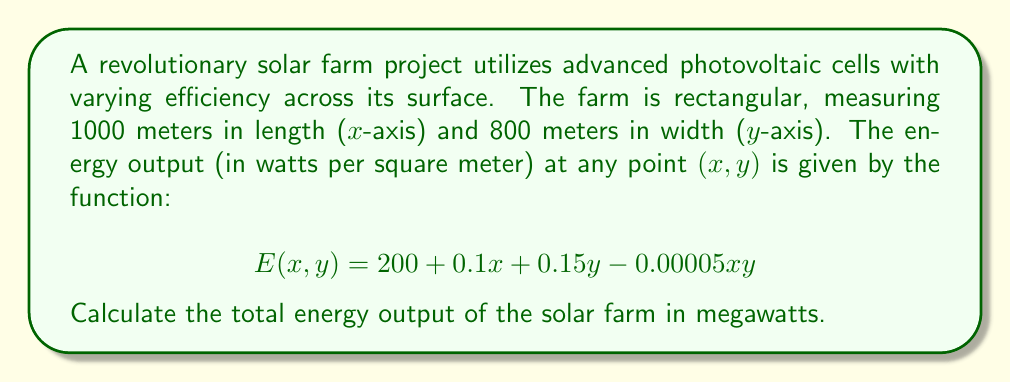Can you answer this question? To calculate the total energy output of the solar farm, we need to integrate the energy output function over the entire area of the farm. This can be done using a double integral.

Step 1: Set up the double integral
The total energy output is given by:
$$\text{Total Energy} = \int_{0}^{800} \int_{0}^{1000} E(x,y) \, dx \, dy$$

Step 2: Substitute the energy function
$$\text{Total Energy} = \int_{0}^{800} \int_{0}^{1000} (200 + 0.1x + 0.15y - 0.00005xy) \, dx \, dy$$

Step 3: Integrate with respect to x
$$\begin{align*}
\text{Total Energy} &= \int_{0}^{800} \left[200x + 0.05x^2 + 0.15xy - 0.000025x^2y\right]_{0}^{1000} \, dy \\
&= \int_{0}^{800} (200000 + 50000 + 150y - 25y) \, dy \\
&= \int_{0}^{800} (250000 + 125y) \, dy
\end{align*}$$

Step 4: Integrate with respect to y
$$\begin{align*}
\text{Total Energy} &= \left[250000y + 62.5y^2\right]_{0}^{800} \\
&= (200000000 + 40000000) - 0 \\
&= 240000000 \text{ watts}
\end{align*}$$

Step 5: Convert to megawatts
$$\text{Total Energy} = 240000000 \, \text{W} \times \frac{1 \, \text{MW}}{1000000 \, \text{W}} = 240 \, \text{MW}$$
Answer: 240 MW 